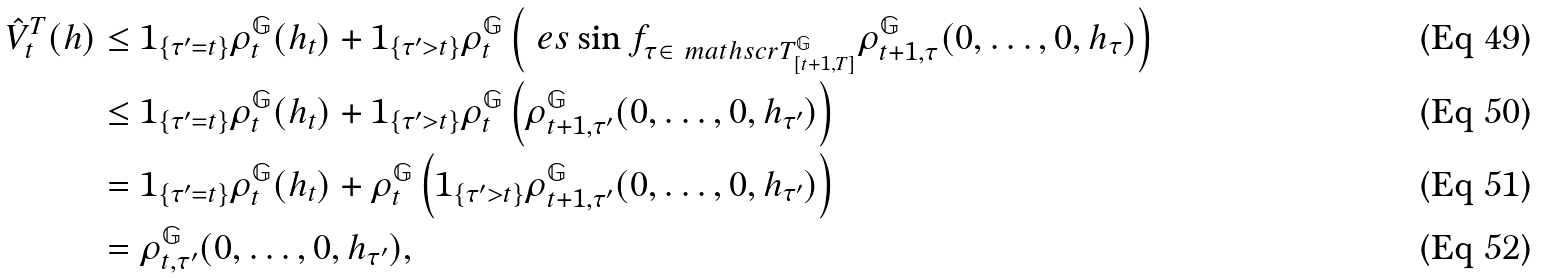Convert formula to latex. <formula><loc_0><loc_0><loc_500><loc_500>\hat { V } ^ { T } _ { t } ( h ) & \leq 1 _ { \{ \tau ^ { \prime } = t \} } \rho ^ { \mathbb { G } } _ { t } ( h _ { t } ) + 1 _ { \{ \tau ^ { \prime } > t \} } \rho ^ { \mathbb { G } } _ { t } \left ( \ e s \sin f _ { \tau \in \ m a t h s c r { T } ^ { \mathbb { G } } _ { [ t + 1 , T ] } } \rho ^ { \mathbb { G } } _ { t + 1 , \tau } ( 0 , \dots , 0 , h _ { \tau } ) \right ) \\ & \leq 1 _ { \{ \tau ^ { \prime } = t \} } \rho ^ { \mathbb { G } } _ { t } ( h _ { t } ) + 1 _ { \{ \tau ^ { \prime } > t \} } \rho ^ { \mathbb { G } } _ { t } \left ( \rho ^ { \mathbb { G } } _ { t + 1 , \tau ^ { \prime } } ( 0 , \dots , 0 , h _ { \tau ^ { \prime } } ) \right ) \\ & = 1 _ { \{ \tau ^ { \prime } = t \} } \rho ^ { \mathbb { G } } _ { t } ( h _ { t } ) + \rho ^ { \mathbb { G } } _ { t } \left ( 1 _ { \{ \tau ^ { \prime } > t \} } \rho ^ { \mathbb { G } } _ { t + 1 , \tau ^ { \prime } } ( 0 , \dots , 0 , h _ { \tau ^ { \prime } } ) \right ) \\ & = \rho ^ { \mathbb { G } } _ { t , \tau ^ { \prime } } ( 0 , \dots , 0 , h _ { \tau ^ { \prime } } ) ,</formula> 